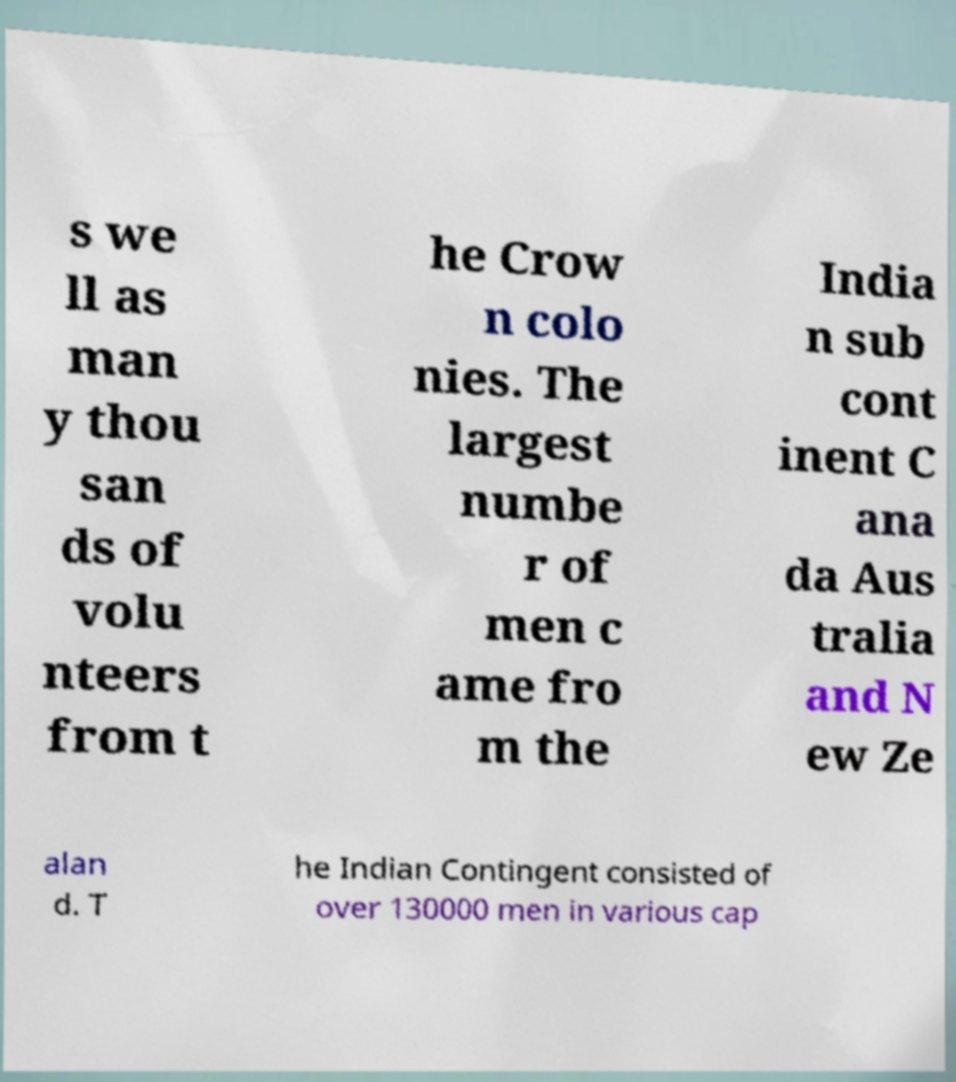Please identify and transcribe the text found in this image. s we ll as man y thou san ds of volu nteers from t he Crow n colo nies. The largest numbe r of men c ame fro m the India n sub cont inent C ana da Aus tralia and N ew Ze alan d. T he Indian Contingent consisted of over 130000 men in various cap 